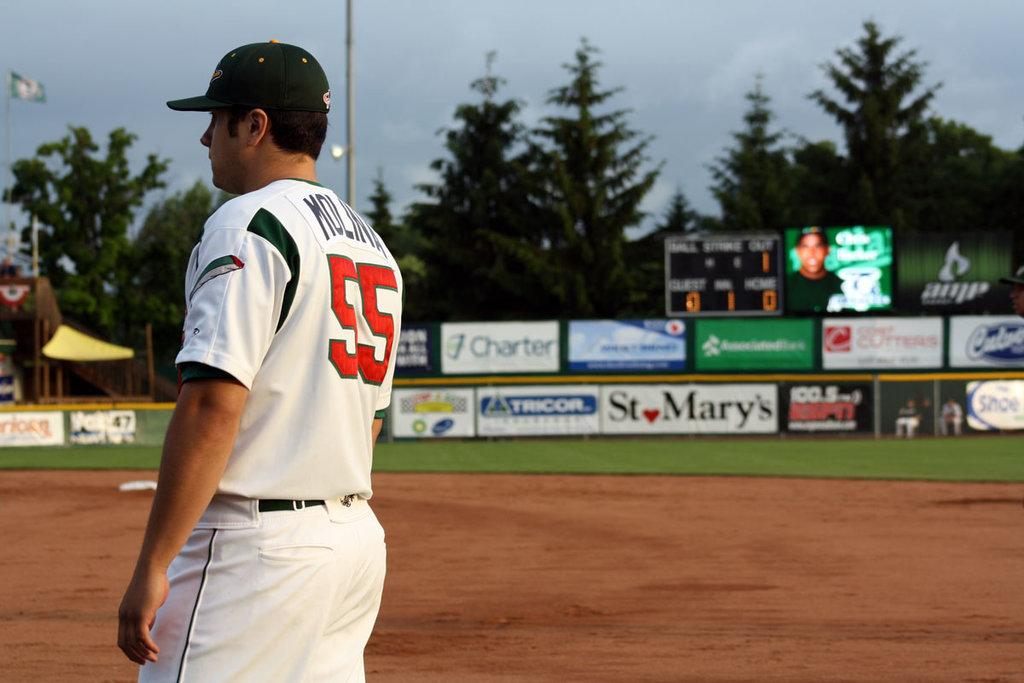<image>
Describe the image concisely. A baseball player standing on a field, wearing a jersey with the number 55 on it. 